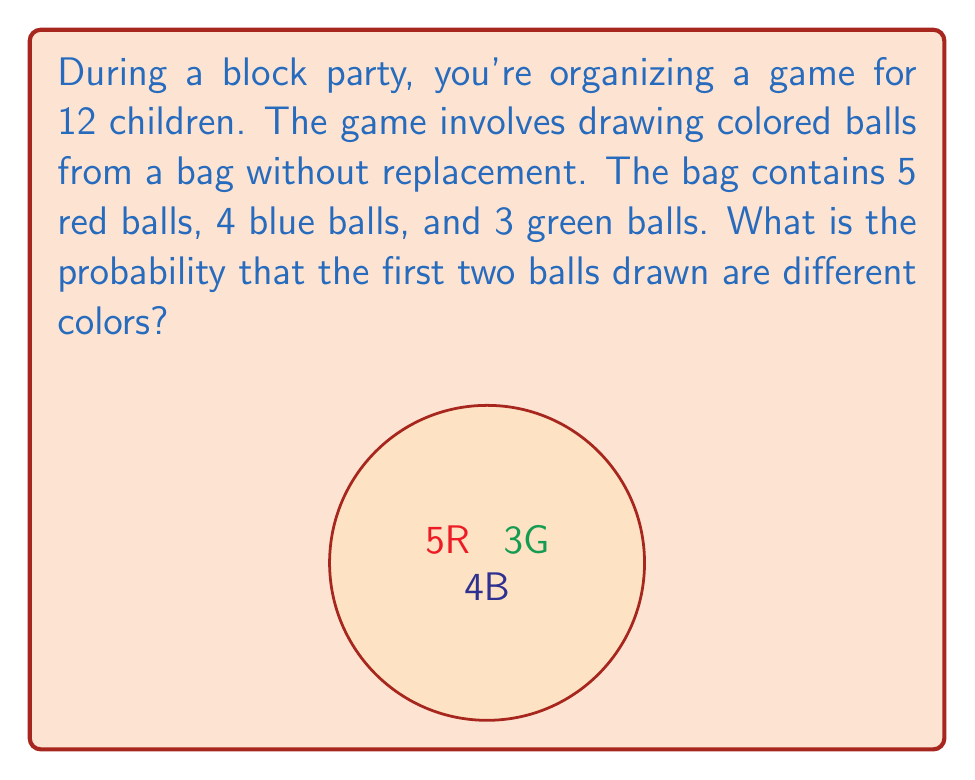Can you solve this math problem? Let's approach this step-by-step:

1) First, we need to calculate the total number of balls:
   $5 + 4 + 3 = 12$ balls in total

2) The probability of drawing different colors can be calculated by adding the probabilities of these scenarios:
   - Red then not Red
   - Blue then not Blue
   - Green then not Green

3) Let's calculate each scenario:

   a) Red then not Red:
      P(Red first) = $\frac{5}{12}$
      P(Not Red second | Red first) = $\frac{7}{11}$
      P(Red then not Red) = $\frac{5}{12} \cdot \frac{7}{11} = \frac{35}{132}$

   b) Blue then not Blue:
      P(Blue first) = $\frac{4}{12} = \frac{1}{3}$
      P(Not Blue second | Blue first) = $\frac{8}{11}$
      P(Blue then not Blue) = $\frac{1}{3} \cdot \frac{8}{11} = \frac{8}{33}$

   c) Green then not Green:
      P(Green first) = $\frac{3}{12} = \frac{1}{4}$
      P(Not Green second | Green first) = $\frac{9}{11}$
      P(Green then not Green) = $\frac{1}{4} \cdot \frac{9}{11} = \frac{9}{44}$

4) Now, we sum these probabilities:
   $\frac{35}{132} + \frac{8}{33} + \frac{9}{44} = \frac{35}{132} + \frac{32}{132} + \frac{27}{132} = \frac{94}{132} = \frac{47}{66}$

Therefore, the probability of drawing two different colored balls is $\frac{47}{66}$.
Answer: $\frac{47}{66}$ 